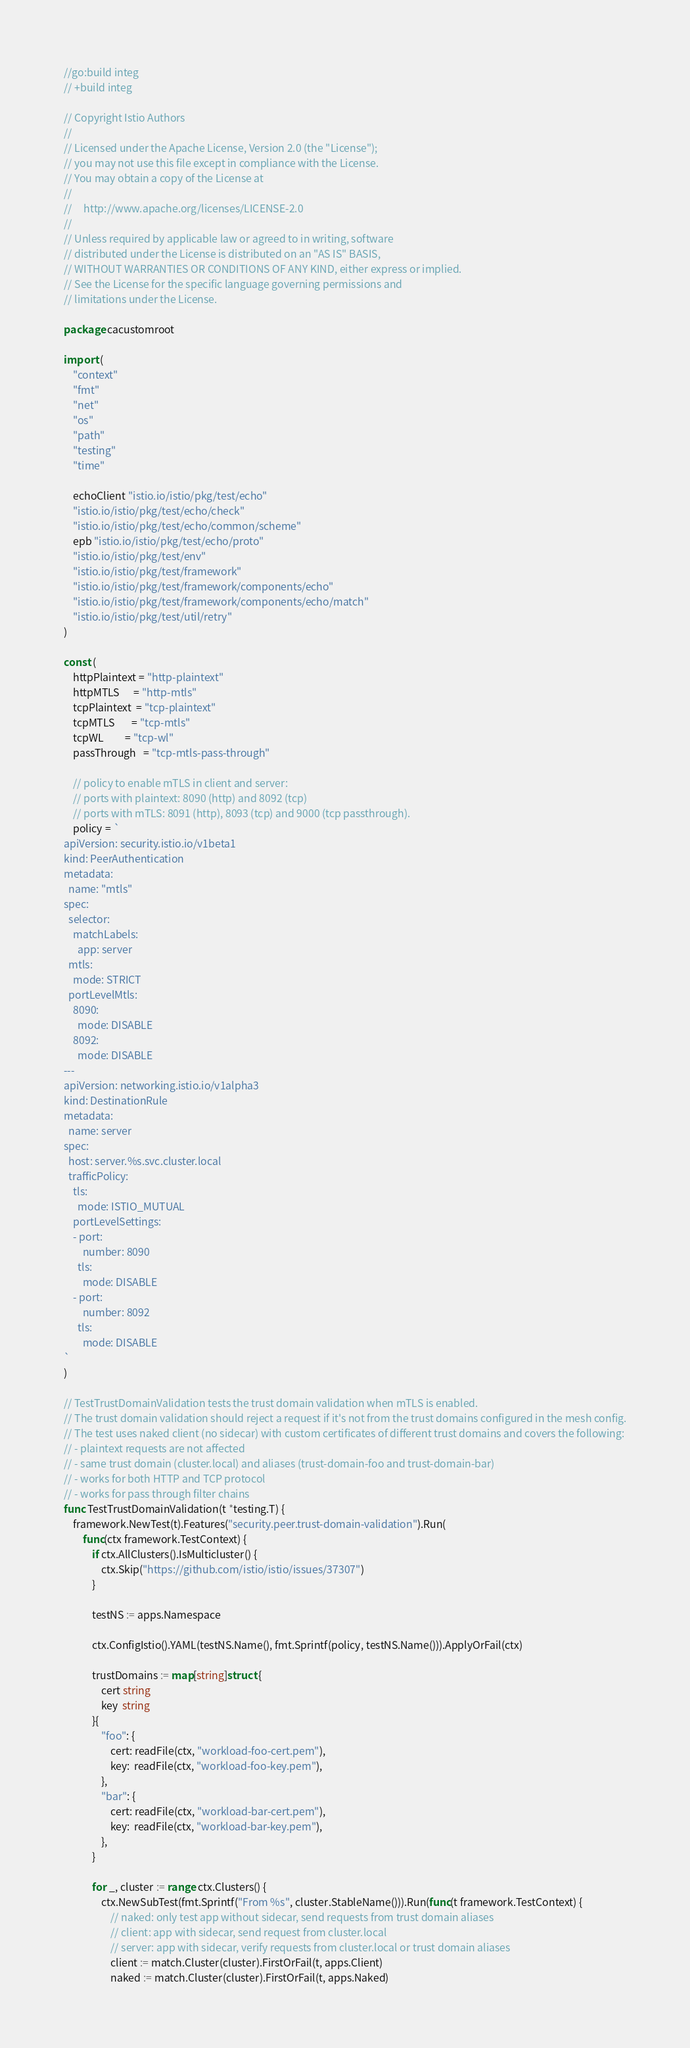<code> <loc_0><loc_0><loc_500><loc_500><_Go_>//go:build integ
// +build integ

// Copyright Istio Authors
//
// Licensed under the Apache License, Version 2.0 (the "License");
// you may not use this file except in compliance with the License.
// You may obtain a copy of the License at
//
//     http://www.apache.org/licenses/LICENSE-2.0
//
// Unless required by applicable law or agreed to in writing, software
// distributed under the License is distributed on an "AS IS" BASIS,
// WITHOUT WARRANTIES OR CONDITIONS OF ANY KIND, either express or implied.
// See the License for the specific language governing permissions and
// limitations under the License.

package cacustomroot

import (
	"context"
	"fmt"
	"net"
	"os"
	"path"
	"testing"
	"time"

	echoClient "istio.io/istio/pkg/test/echo"
	"istio.io/istio/pkg/test/echo/check"
	"istio.io/istio/pkg/test/echo/common/scheme"
	epb "istio.io/istio/pkg/test/echo/proto"
	"istio.io/istio/pkg/test/env"
	"istio.io/istio/pkg/test/framework"
	"istio.io/istio/pkg/test/framework/components/echo"
	"istio.io/istio/pkg/test/framework/components/echo/match"
	"istio.io/istio/pkg/test/util/retry"
)

const (
	httpPlaintext = "http-plaintext"
	httpMTLS      = "http-mtls"
	tcpPlaintext  = "tcp-plaintext"
	tcpMTLS       = "tcp-mtls"
	tcpWL         = "tcp-wl"
	passThrough   = "tcp-mtls-pass-through"

	// policy to enable mTLS in client and server:
	// ports with plaintext: 8090 (http) and 8092 (tcp)
	// ports with mTLS: 8091 (http), 8093 (tcp) and 9000 (tcp passthrough).
	policy = `
apiVersion: security.istio.io/v1beta1
kind: PeerAuthentication
metadata:
  name: "mtls"
spec:
  selector:
    matchLabels:
      app: server
  mtls:
    mode: STRICT
  portLevelMtls:
    8090:
      mode: DISABLE
    8092:
      mode: DISABLE
---
apiVersion: networking.istio.io/v1alpha3
kind: DestinationRule
metadata:
  name: server
spec:
  host: server.%s.svc.cluster.local
  trafficPolicy:
    tls:
      mode: ISTIO_MUTUAL
    portLevelSettings:
    - port:
        number: 8090
      tls:
        mode: DISABLE
    - port:
        number: 8092
      tls:
        mode: DISABLE
`
)

// TestTrustDomainValidation tests the trust domain validation when mTLS is enabled.
// The trust domain validation should reject a request if it's not from the trust domains configured in the mesh config.
// The test uses naked client (no sidecar) with custom certificates of different trust domains and covers the following:
// - plaintext requests are not affected
// - same trust domain (cluster.local) and aliases (trust-domain-foo and trust-domain-bar)
// - works for both HTTP and TCP protocol
// - works for pass through filter chains
func TestTrustDomainValidation(t *testing.T) {
	framework.NewTest(t).Features("security.peer.trust-domain-validation").Run(
		func(ctx framework.TestContext) {
			if ctx.AllClusters().IsMulticluster() {
				ctx.Skip("https://github.com/istio/istio/issues/37307")
			}

			testNS := apps.Namespace

			ctx.ConfigIstio().YAML(testNS.Name(), fmt.Sprintf(policy, testNS.Name())).ApplyOrFail(ctx)

			trustDomains := map[string]struct {
				cert string
				key  string
			}{
				"foo": {
					cert: readFile(ctx, "workload-foo-cert.pem"),
					key:  readFile(ctx, "workload-foo-key.pem"),
				},
				"bar": {
					cert: readFile(ctx, "workload-bar-cert.pem"),
					key:  readFile(ctx, "workload-bar-key.pem"),
				},
			}

			for _, cluster := range ctx.Clusters() {
				ctx.NewSubTest(fmt.Sprintf("From %s", cluster.StableName())).Run(func(t framework.TestContext) {
					// naked: only test app without sidecar, send requests from trust domain aliases
					// client: app with sidecar, send request from cluster.local
					// server: app with sidecar, verify requests from cluster.local or trust domain aliases
					client := match.Cluster(cluster).FirstOrFail(t, apps.Client)
					naked := match.Cluster(cluster).FirstOrFail(t, apps.Naked)</code> 